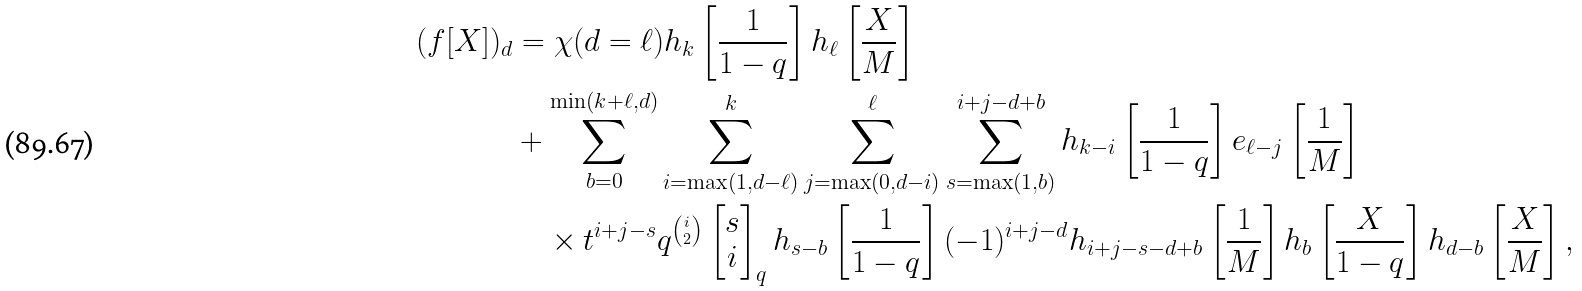Convert formula to latex. <formula><loc_0><loc_0><loc_500><loc_500>( f [ X ] ) _ { d } & = \chi ( d = \ell ) h _ { k } \left [ \frac { 1 } { 1 - q } \right ] h _ { \ell } \left [ \frac { X } { M } \right ] \\ & + \sum _ { b = 0 } ^ { \min ( k + \ell , d ) } \sum _ { i = \max ( 1 , d - \ell ) } ^ { k } \sum _ { j = \max ( 0 , d - i ) } ^ { \ell } \sum _ { s = \max ( 1 , b ) } ^ { i + j - d + b } h _ { k - i } \left [ \frac { 1 } { 1 - q } \right ] e _ { \ell - j } \left [ \frac { 1 } { M } \right ] \\ & \quad \times t ^ { i + j - s } q ^ { \binom { i } { 2 } } \begin{bmatrix} s \\ i \end{bmatrix} _ { q } h _ { s - b } \left [ \frac { 1 } { 1 - q } \right ] ( - 1 ) ^ { i + j - d } h _ { i + j - s - d + b } \left [ \frac { 1 } { M } \right ] h _ { b } \left [ \frac { X } { 1 - q } \right ] h _ { d - b } \left [ \frac { X } { M } \right ] ,</formula> 